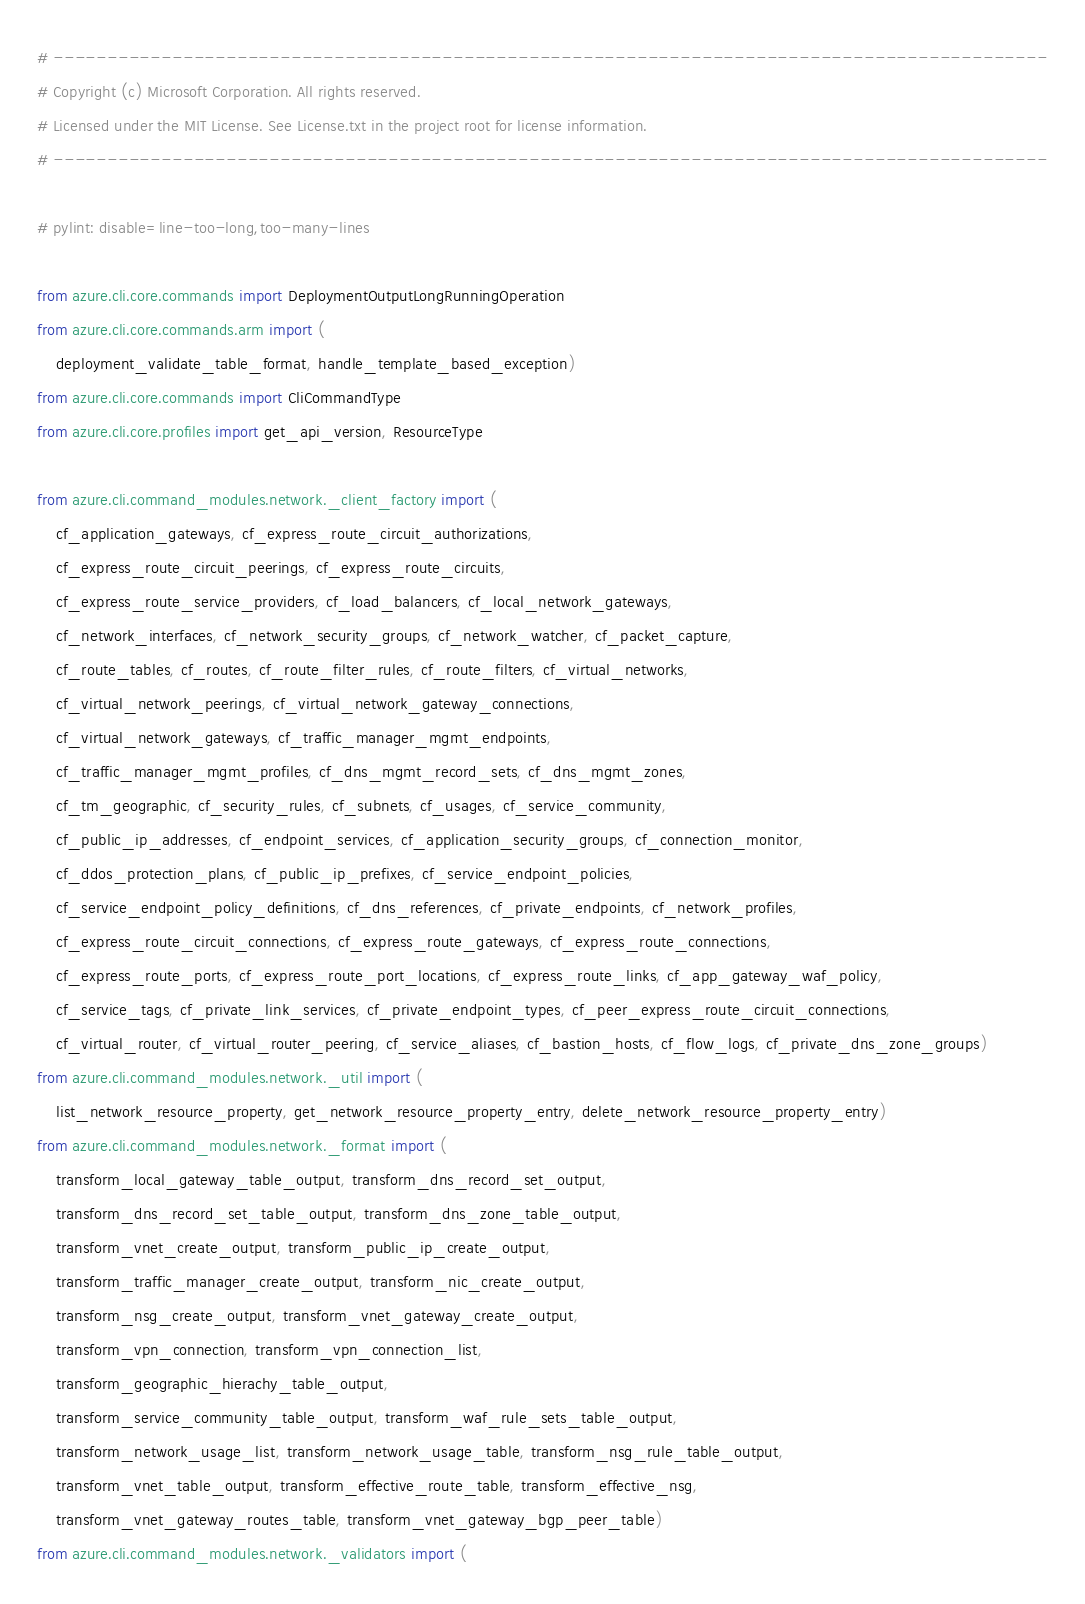<code> <loc_0><loc_0><loc_500><loc_500><_Python_># --------------------------------------------------------------------------------------------
# Copyright (c) Microsoft Corporation. All rights reserved.
# Licensed under the MIT License. See License.txt in the project root for license information.
# --------------------------------------------------------------------------------------------

# pylint: disable=line-too-long,too-many-lines

from azure.cli.core.commands import DeploymentOutputLongRunningOperation
from azure.cli.core.commands.arm import (
    deployment_validate_table_format, handle_template_based_exception)
from azure.cli.core.commands import CliCommandType
from azure.cli.core.profiles import get_api_version, ResourceType

from azure.cli.command_modules.network._client_factory import (
    cf_application_gateways, cf_express_route_circuit_authorizations,
    cf_express_route_circuit_peerings, cf_express_route_circuits,
    cf_express_route_service_providers, cf_load_balancers, cf_local_network_gateways,
    cf_network_interfaces, cf_network_security_groups, cf_network_watcher, cf_packet_capture,
    cf_route_tables, cf_routes, cf_route_filter_rules, cf_route_filters, cf_virtual_networks,
    cf_virtual_network_peerings, cf_virtual_network_gateway_connections,
    cf_virtual_network_gateways, cf_traffic_manager_mgmt_endpoints,
    cf_traffic_manager_mgmt_profiles, cf_dns_mgmt_record_sets, cf_dns_mgmt_zones,
    cf_tm_geographic, cf_security_rules, cf_subnets, cf_usages, cf_service_community,
    cf_public_ip_addresses, cf_endpoint_services, cf_application_security_groups, cf_connection_monitor,
    cf_ddos_protection_plans, cf_public_ip_prefixes, cf_service_endpoint_policies,
    cf_service_endpoint_policy_definitions, cf_dns_references, cf_private_endpoints, cf_network_profiles,
    cf_express_route_circuit_connections, cf_express_route_gateways, cf_express_route_connections,
    cf_express_route_ports, cf_express_route_port_locations, cf_express_route_links, cf_app_gateway_waf_policy,
    cf_service_tags, cf_private_link_services, cf_private_endpoint_types, cf_peer_express_route_circuit_connections,
    cf_virtual_router, cf_virtual_router_peering, cf_service_aliases, cf_bastion_hosts, cf_flow_logs, cf_private_dns_zone_groups)
from azure.cli.command_modules.network._util import (
    list_network_resource_property, get_network_resource_property_entry, delete_network_resource_property_entry)
from azure.cli.command_modules.network._format import (
    transform_local_gateway_table_output, transform_dns_record_set_output,
    transform_dns_record_set_table_output, transform_dns_zone_table_output,
    transform_vnet_create_output, transform_public_ip_create_output,
    transform_traffic_manager_create_output, transform_nic_create_output,
    transform_nsg_create_output, transform_vnet_gateway_create_output,
    transform_vpn_connection, transform_vpn_connection_list,
    transform_geographic_hierachy_table_output,
    transform_service_community_table_output, transform_waf_rule_sets_table_output,
    transform_network_usage_list, transform_network_usage_table, transform_nsg_rule_table_output,
    transform_vnet_table_output, transform_effective_route_table, transform_effective_nsg,
    transform_vnet_gateway_routes_table, transform_vnet_gateway_bgp_peer_table)
from azure.cli.command_modules.network._validators import (</code> 